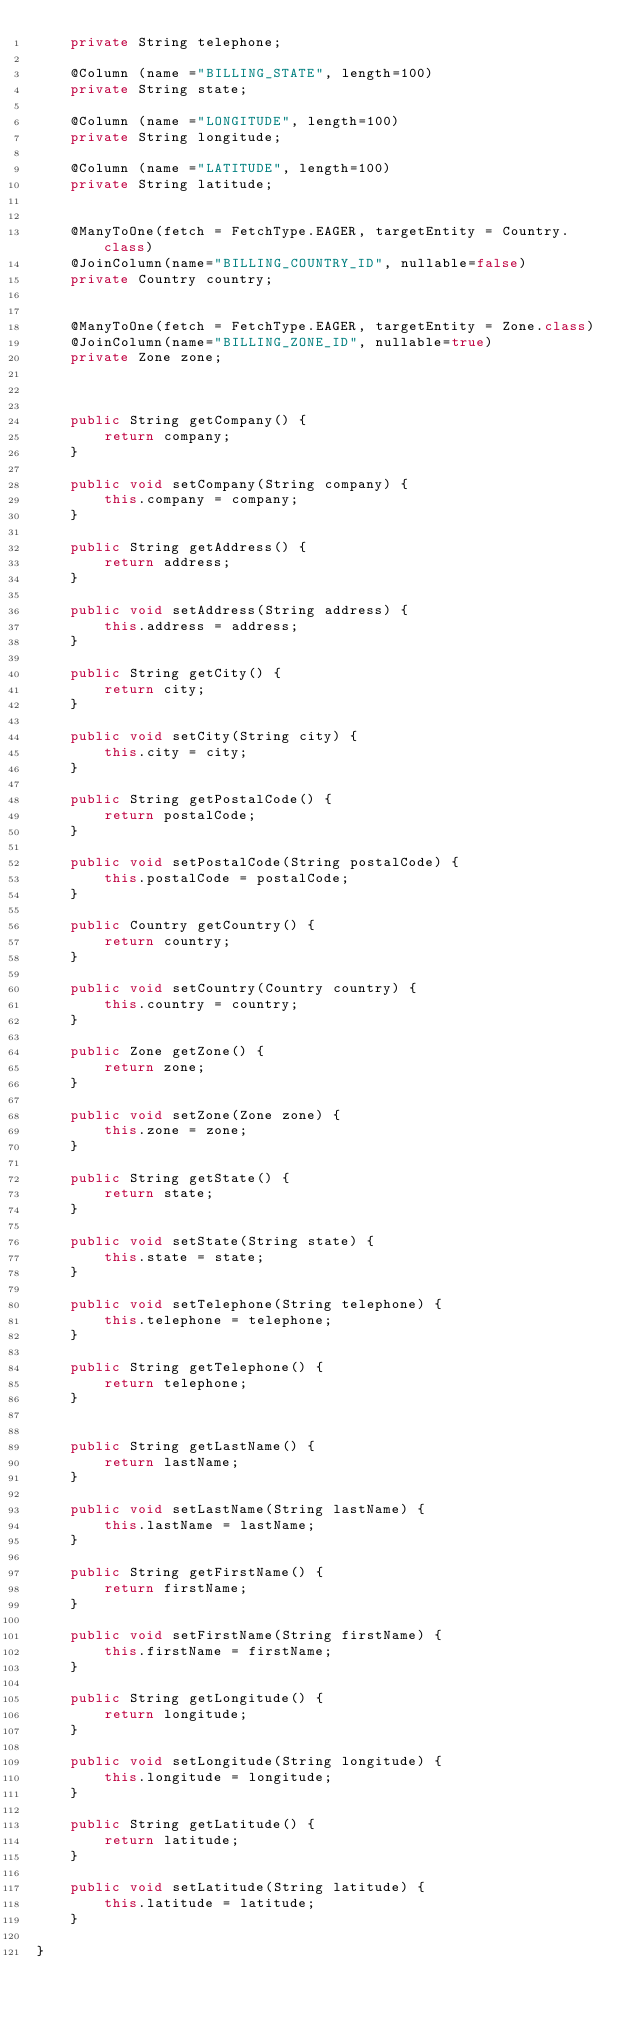<code> <loc_0><loc_0><loc_500><loc_500><_Java_>	private String telephone;
	
	@Column (name ="BILLING_STATE", length=100)
	private String state;
	
	@Column (name ="LONGITUDE", length=100)
	private String longitude;
	
	@Column (name ="LATITUDE", length=100)
	private String latitude;


	@ManyToOne(fetch = FetchType.EAGER, targetEntity = Country.class)
	@JoinColumn(name="BILLING_COUNTRY_ID", nullable=false)
	private Country country;
	
	
	@ManyToOne(fetch = FetchType.EAGER, targetEntity = Zone.class)
	@JoinColumn(name="BILLING_ZONE_ID", nullable=true)
	private Zone zone;



	public String getCompany() {
		return company;
	}

	public void setCompany(String company) {
		this.company = company;
	}

	public String getAddress() {
		return address;
	}

	public void setAddress(String address) {
		this.address = address;
	}

	public String getCity() {
		return city;
	}

	public void setCity(String city) {
		this.city = city;
	}

	public String getPostalCode() {
		return postalCode;
	}

	public void setPostalCode(String postalCode) {
		this.postalCode = postalCode;
	}
	
	public Country getCountry() {
		return country;
	}

	public void setCountry(Country country) {
		this.country = country;
	}

	public Zone getZone() {
		return zone;
	}

	public void setZone(Zone zone) {
		this.zone = zone;
	}
	
	public String getState() {
		return state;
	}

	public void setState(String state) {
		this.state = state;
	}

	public void setTelephone(String telephone) {
		this.telephone = telephone;
	}

	public String getTelephone() {
		return telephone;
	}
	
	
	public String getLastName() {
		return lastName;
	}

	public void setLastName(String lastName) {
		this.lastName = lastName;
	}
	
	public String getFirstName() {
		return firstName;
	}

	public void setFirstName(String firstName) {
		this.firstName = firstName;
	}

	public String getLongitude() {
		return longitude;
	}

	public void setLongitude(String longitude) {
		this.longitude = longitude;
	}

	public String getLatitude() {
		return latitude;
	}

	public void setLatitude(String latitude) {
		this.latitude = latitude;
	}
	
}
</code> 